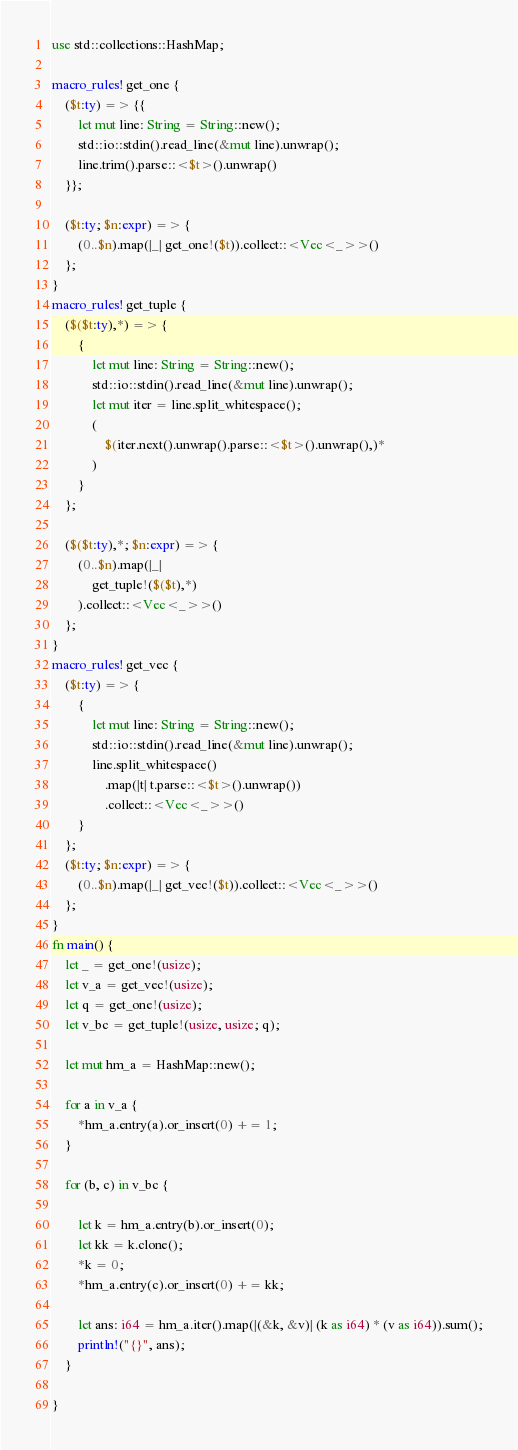<code> <loc_0><loc_0><loc_500><loc_500><_Rust_>use std::collections::HashMap;

macro_rules! get_one {
    ($t:ty) => {{
        let mut line: String = String::new();
        std::io::stdin().read_line(&mut line).unwrap();
        line.trim().parse::<$t>().unwrap()
    }};

    ($t:ty; $n:expr) => {
        (0..$n).map(|_| get_one!($t)).collect::<Vec<_>>()
    };
}
macro_rules! get_tuple {
    ($($t:ty),*) => {
        {
            let mut line: String = String::new();
            std::io::stdin().read_line(&mut line).unwrap();
            let mut iter = line.split_whitespace();
            (
                $(iter.next().unwrap().parse::<$t>().unwrap(),)*
            )
        }
    };

    ($($t:ty),*; $n:expr) => {
        (0..$n).map(|_|
            get_tuple!($($t),*)
        ).collect::<Vec<_>>()
    };
}
macro_rules! get_vec {
    ($t:ty) => {
        {
            let mut line: String = String::new();
            std::io::stdin().read_line(&mut line).unwrap();
            line.split_whitespace()
                .map(|t| t.parse::<$t>().unwrap())
                .collect::<Vec<_>>()
        }
    };
    ($t:ty; $n:expr) => {
        (0..$n).map(|_| get_vec!($t)).collect::<Vec<_>>()
    };
}
fn main() {
    let _ = get_one!(usize);
    let v_a = get_vec!(usize);
    let q = get_one!(usize);
    let v_bc = get_tuple!(usize, usize; q);

    let mut hm_a = HashMap::new();

    for a in v_a {
        *hm_a.entry(a).or_insert(0) += 1;
    }

    for (b, c) in v_bc {

        let k = hm_a.entry(b).or_insert(0);
        let kk = k.clone();
        *k = 0;
        *hm_a.entry(c).or_insert(0) += kk;

        let ans: i64 = hm_a.iter().map(|(&k, &v)| (k as i64) * (v as i64)).sum();
        println!("{}", ans);
    }

}
</code> 